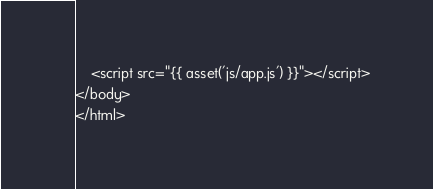<code> <loc_0><loc_0><loc_500><loc_500><_PHP_>    <script src="{{ asset('js/app.js') }}"></script>
</body>
</html>
</code> 